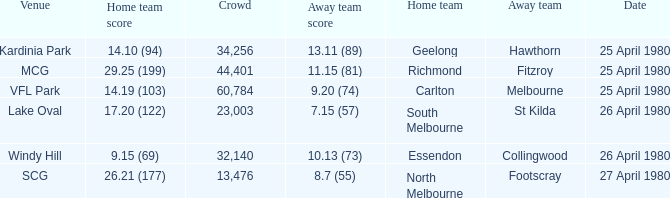What was the lowest crowd size at MCG? 44401.0. 